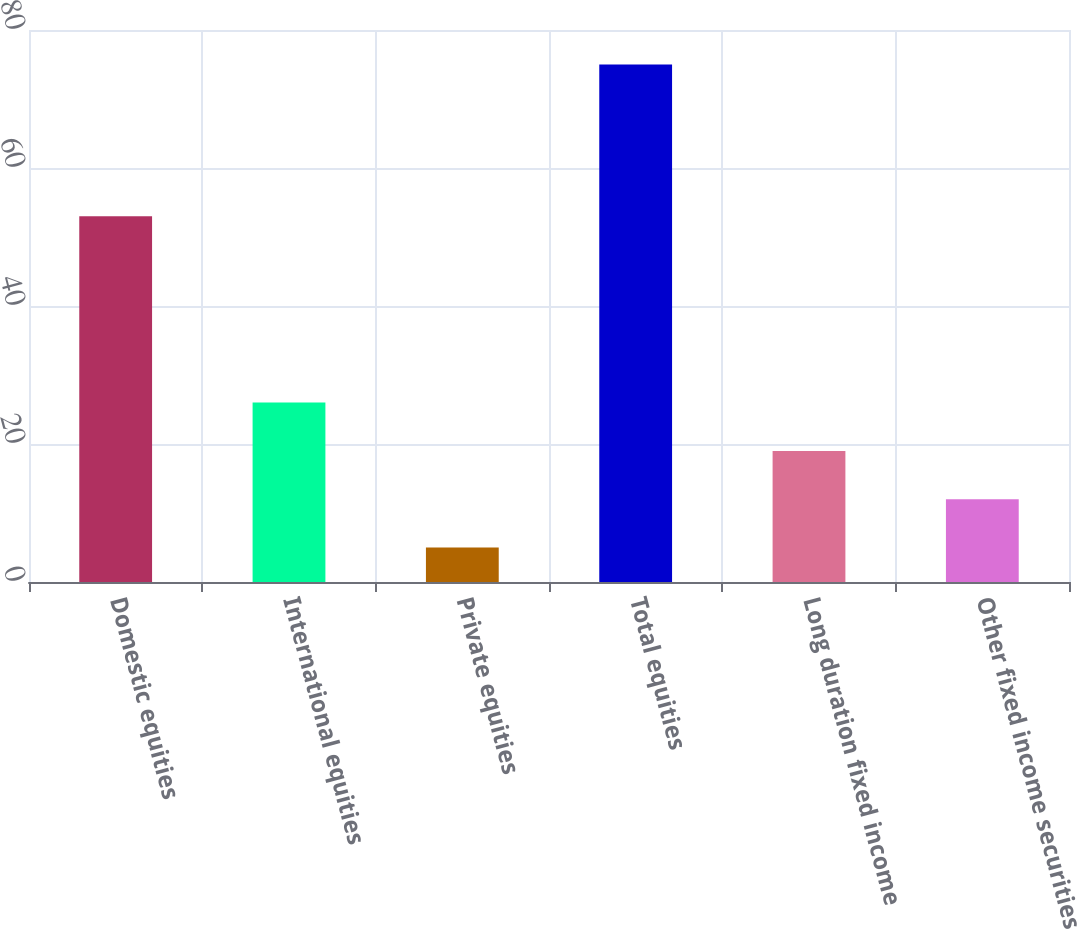Convert chart to OTSL. <chart><loc_0><loc_0><loc_500><loc_500><bar_chart><fcel>Domestic equities<fcel>International equities<fcel>Private equities<fcel>Total equities<fcel>Long duration fixed income<fcel>Other fixed income securities<nl><fcel>53<fcel>26<fcel>5<fcel>75<fcel>19<fcel>12<nl></chart> 